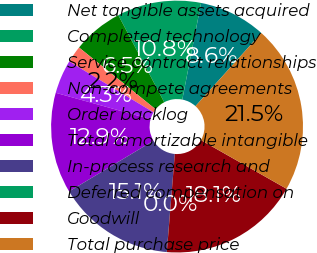Convert chart. <chart><loc_0><loc_0><loc_500><loc_500><pie_chart><fcel>Net tangible assets acquired<fcel>Completed technology<fcel>Service contract relationships<fcel>Non-compete agreements<fcel>Order backlog<fcel>Total amortizable intangible<fcel>In-process research and<fcel>Deferred compensation on<fcel>Goodwill<fcel>Total purchase price<nl><fcel>8.62%<fcel>10.78%<fcel>6.47%<fcel>2.16%<fcel>4.32%<fcel>12.93%<fcel>15.08%<fcel>0.01%<fcel>18.07%<fcel>21.54%<nl></chart> 